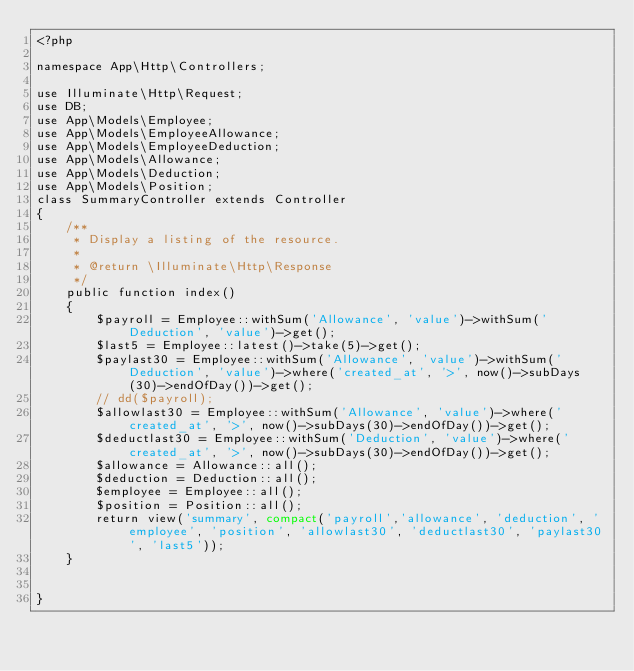Convert code to text. <code><loc_0><loc_0><loc_500><loc_500><_PHP_><?php

namespace App\Http\Controllers;

use Illuminate\Http\Request;
use DB;
use App\Models\Employee;
use App\Models\EmployeeAllowance;
use App\Models\EmployeeDeduction;
use App\Models\Allowance;
use App\Models\Deduction;
use App\Models\Position;
class SummaryController extends Controller
{
    /**
     * Display a listing of the resource.
     *
     * @return \Illuminate\Http\Response
     */
    public function index()
    {
        $payroll = Employee::withSum('Allowance', 'value')->withSum('Deduction', 'value')->get();
        $last5 = Employee::latest()->take(5)->get();
        $paylast30 = Employee::withSum('Allowance', 'value')->withSum('Deduction', 'value')->where('created_at', '>', now()->subDays(30)->endOfDay())->get();
        // dd($payroll);
        $allowlast30 = Employee::withSum('Allowance', 'value')->where('created_at', '>', now()->subDays(30)->endOfDay())->get();
        $deductlast30 = Employee::withSum('Deduction', 'value')->where('created_at', '>', now()->subDays(30)->endOfDay())->get();
        $allowance = Allowance::all();
        $deduction = Deduction::all();
        $employee = Employee::all();
        $position = Position::all();
        return view('summary', compact('payroll','allowance', 'deduction', 'employee', 'position', 'allowlast30', 'deductlast30', 'paylast30', 'last5'));
    }

    
}
</code> 